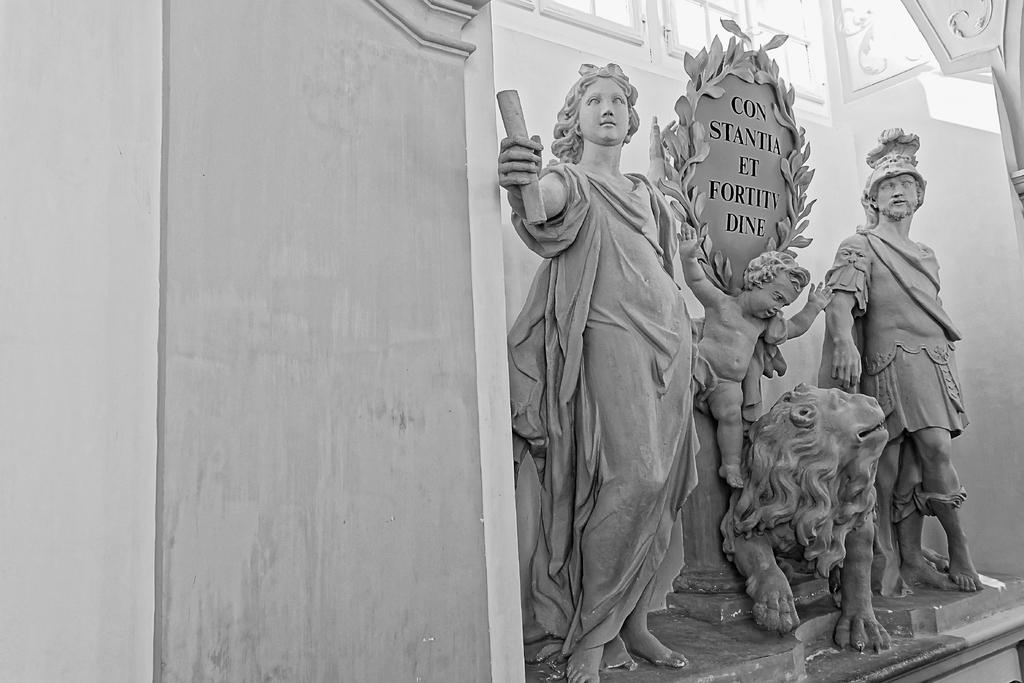What can be seen on the left side of the image? There are sculptures of a woman, kid, lion, and a man on the left side of the image. What is located at the top of the image? There are windows at the top of the image. What color is the wall on the right side of the image? The wall on the right side of the image is painted white. How many letters are being shaken by the van in the image? There is no van or letters present in the image. 